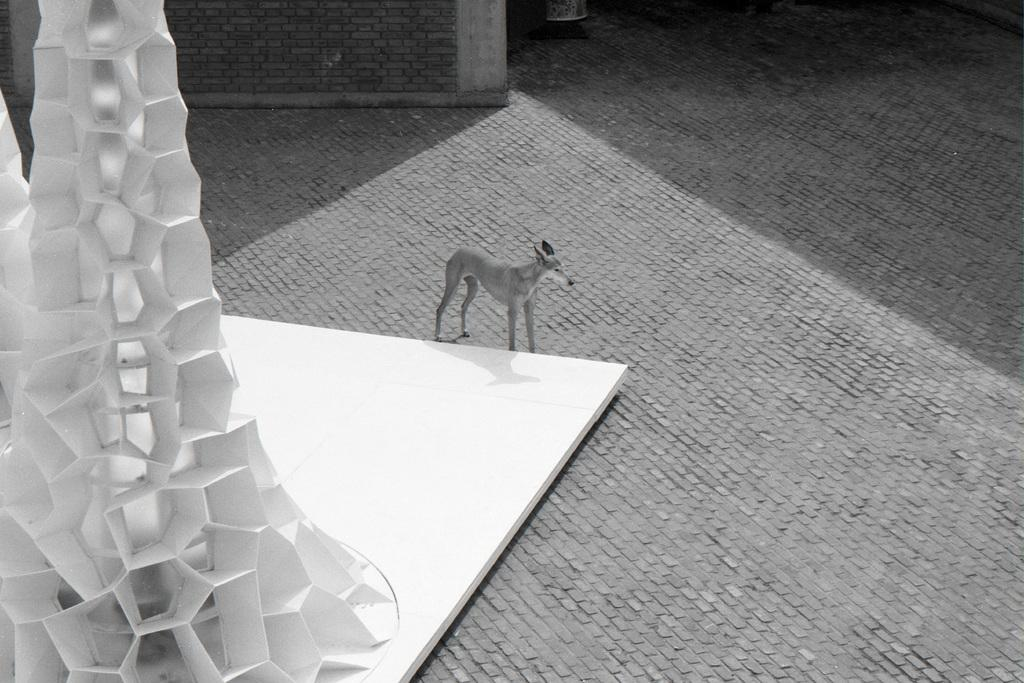What is the color scheme of the image? The image is black and white. What animal can be seen in the image? There is a dog in the image. What object is on the left side of the image? There is a white color object on the left side of the image. What surface is visible at the bottom of the image? There is a floor at the bottom of the image. What scientific experiment is being conducted in the image? There is no scientific experiment visible in the image; it features a dog and a white object on a floor. Can you see any sea creatures in the image? There are no sea creatures present in the image. 